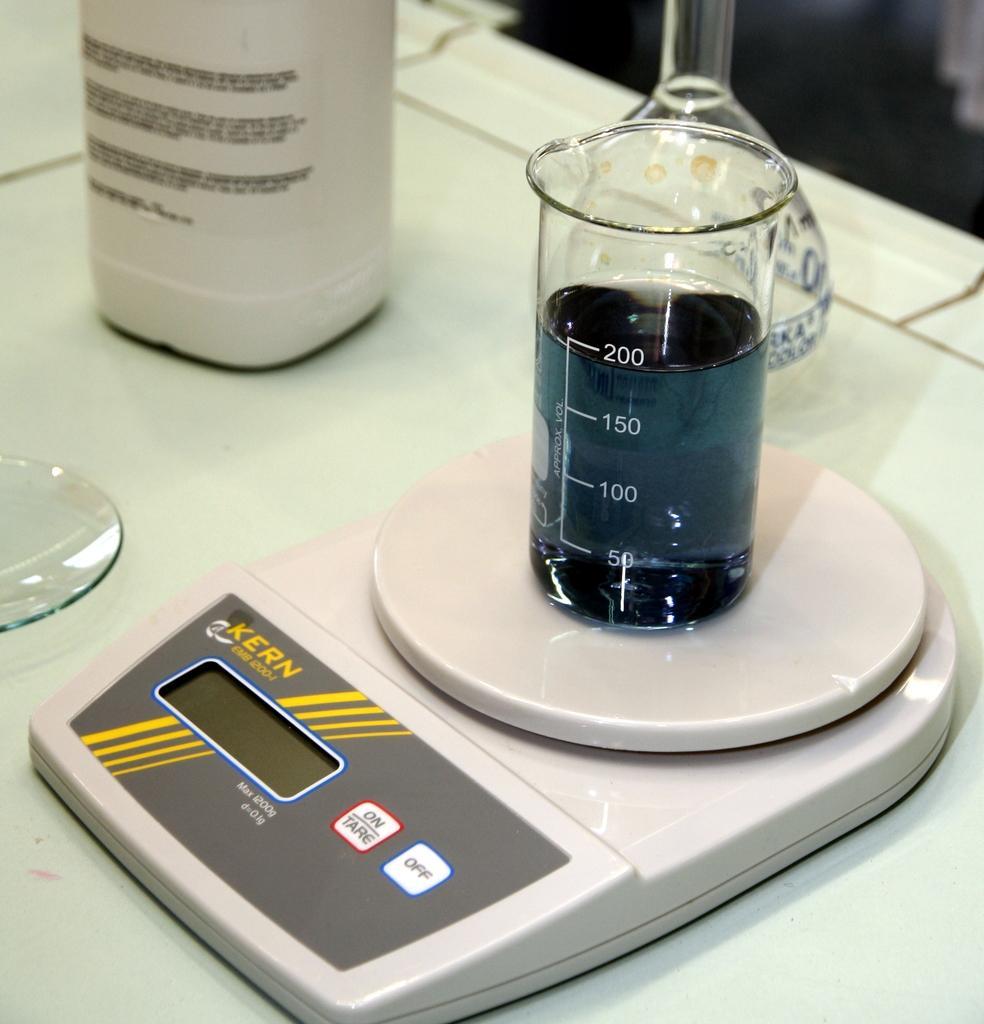In one or two sentences, can you explain what this image depicts? In this picture we can see the platform and on this platform we can see a glass, beaker and some objects. 